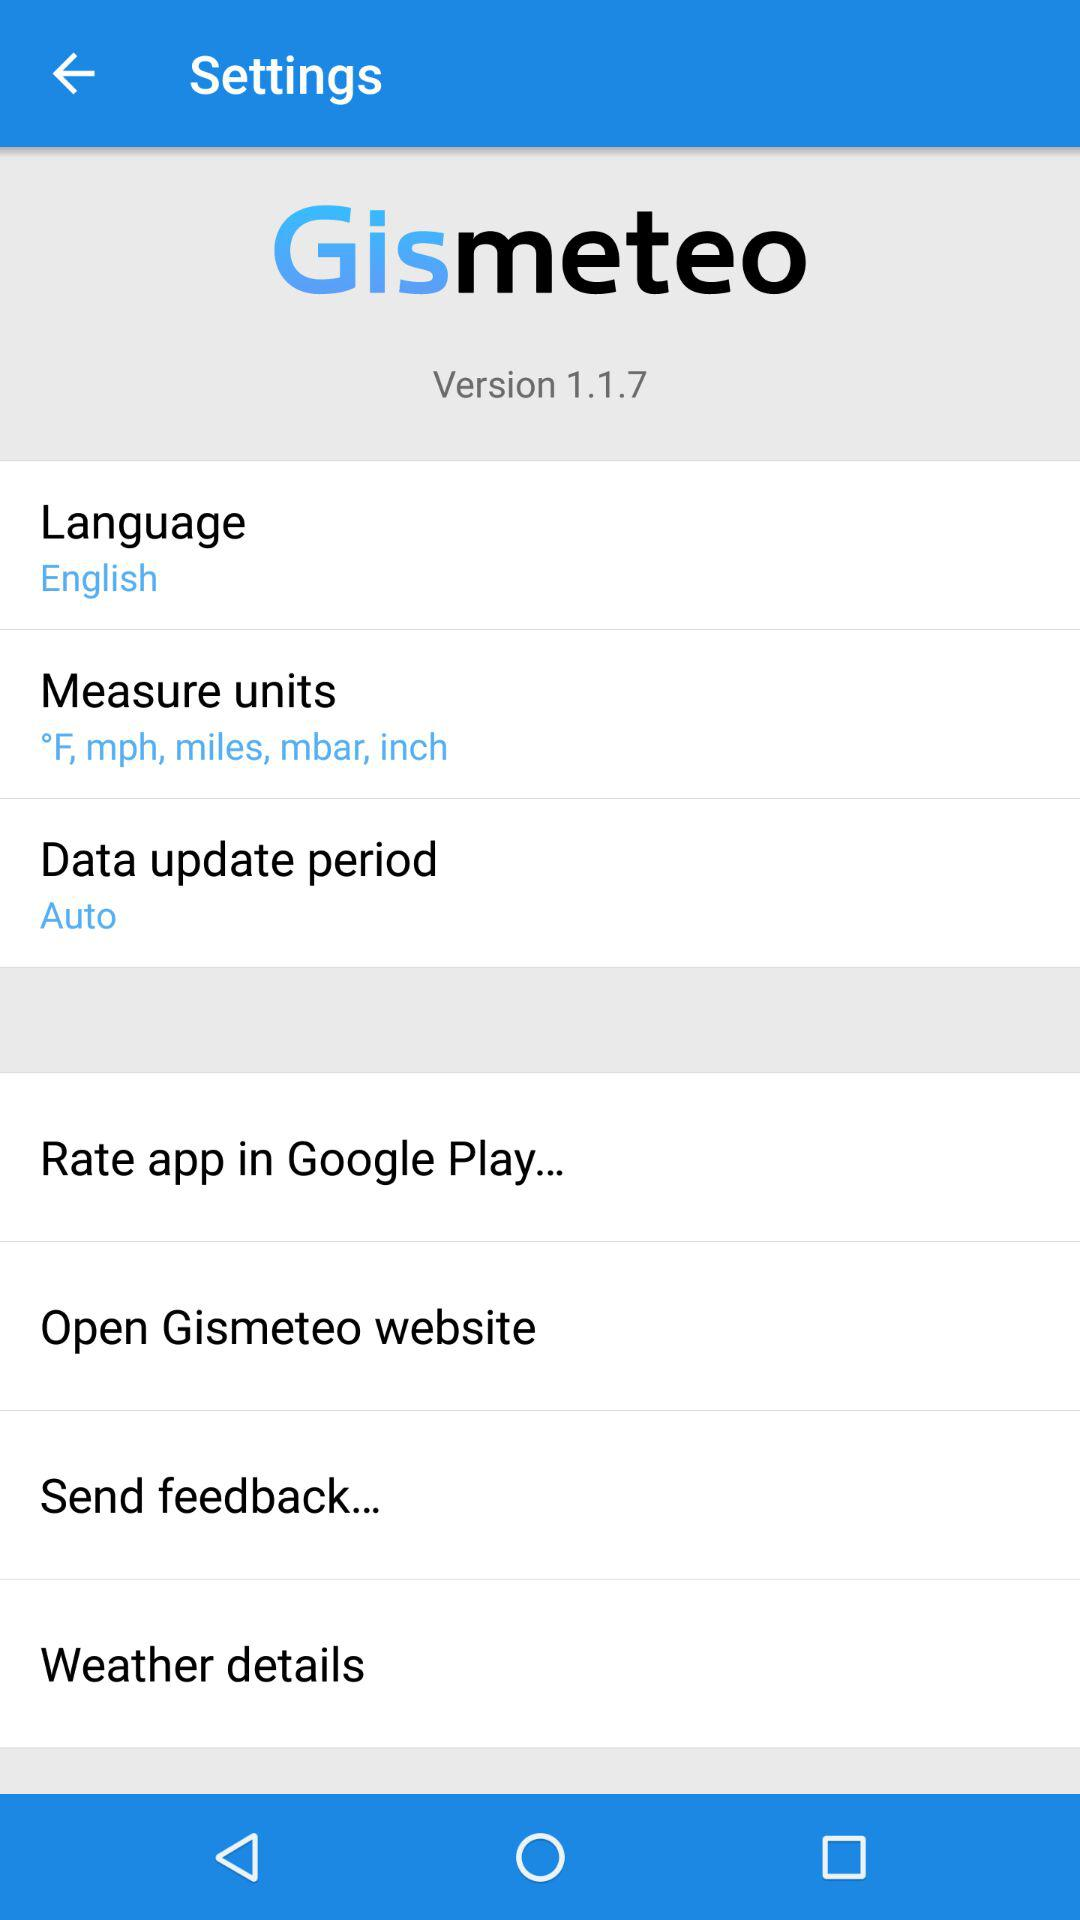What is the application name? The application name is "Gismeteo". 